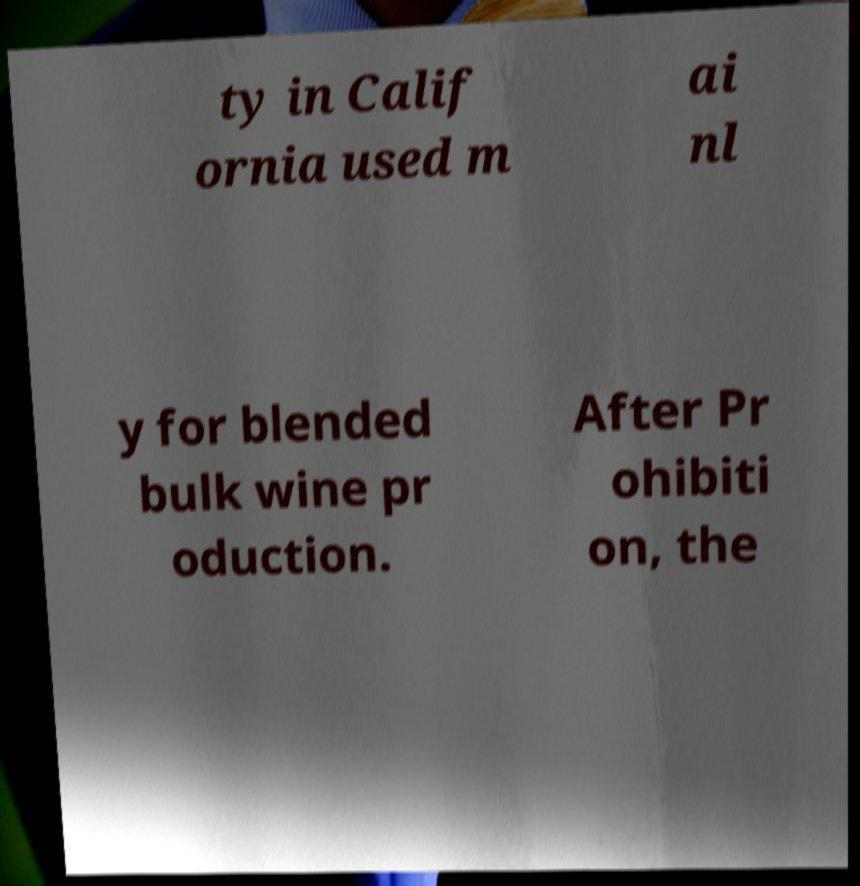Can you accurately transcribe the text from the provided image for me? ty in Calif ornia used m ai nl y for blended bulk wine pr oduction. After Pr ohibiti on, the 